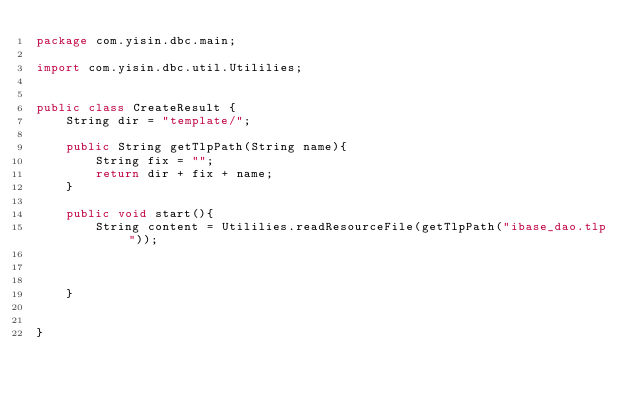Convert code to text. <code><loc_0><loc_0><loc_500><loc_500><_Java_>package com.yisin.dbc.main;

import com.yisin.dbc.util.Utililies;


public class CreateResult {
    String dir = "template/";
    
    public String getTlpPath(String name){
        String fix = "";
        return dir + fix + name;
    }
    
    public void start(){
        String content = Utililies.readResourceFile(getTlpPath("ibase_dao.tlp"));
        
        
        
    }
    
    
}
</code> 